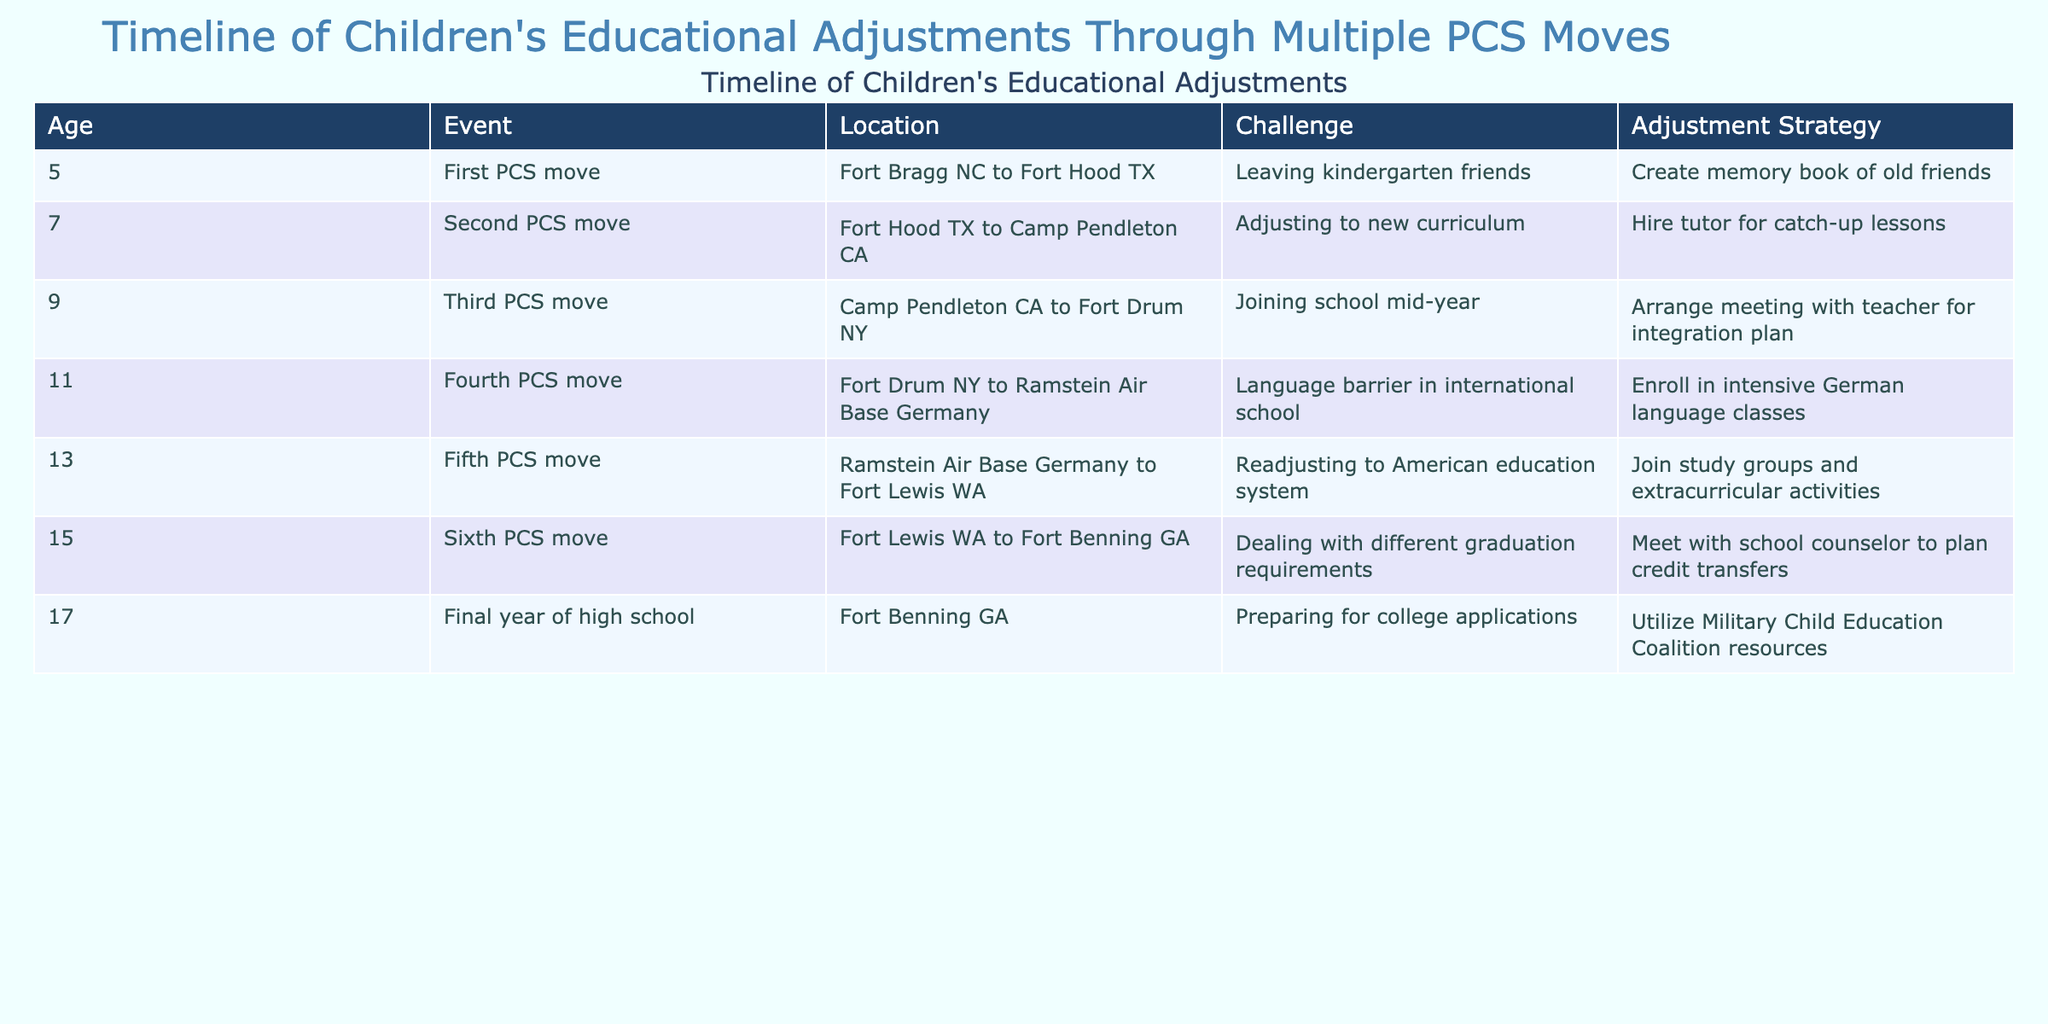What was the age of the child during the first PCS move? The child was 5 years old during the first PCS move as indicated in the table.
Answer: 5 What challenge did the child face when moving from Fort Bragg NC to Fort Hood TX? The challenge faced was leaving kindergarten friends, as documented in the table.
Answer: Leaving kindergarten friends How many PCS moves did the child experience before high school? The table lists five PCS moves prior to the final year of high school, specifically moves at ages 5, 7, 9, 11, and 13.
Answer: 5 Did the child utilize any resources for college applications? Yes, the child utilized resources from the Military Child Education Coalition during the final year of high school.
Answer: Yes What adjustment strategy was used after the fifth PCS move? The child joined study groups and extracurricular activities after the fifth PCS move to adjust to the American education system.
Answer: Join study groups and extracurricular activities What was the main challenge identified during the fourth PCS move? The main challenge was dealing with a language barrier in the international school.
Answer: Language barrier in international school How many different states did the child move to during the PCS moves listed? The child moved to three different states: Texas (Fort Hood), California (Camp Pendleton), and New York (Fort Drum) before moving internationally to Germany.
Answer: 3 What was the adjustment strategy for joining school mid-year? The adjustment strategy was to arrange a meeting with the teacher for an integration plan to help with the transition.
Answer: Arrange meeting with teacher for integration plan What is the overall trend in challenges faced by the child from the first PCS move to high school graduation? The challenges evolved from social adjustments to academic adjustments and finally preparing for college applications, indicating a progression from emotional to educational difficulties as the child aged.
Answer: Progression from emotional to educational difficulties 